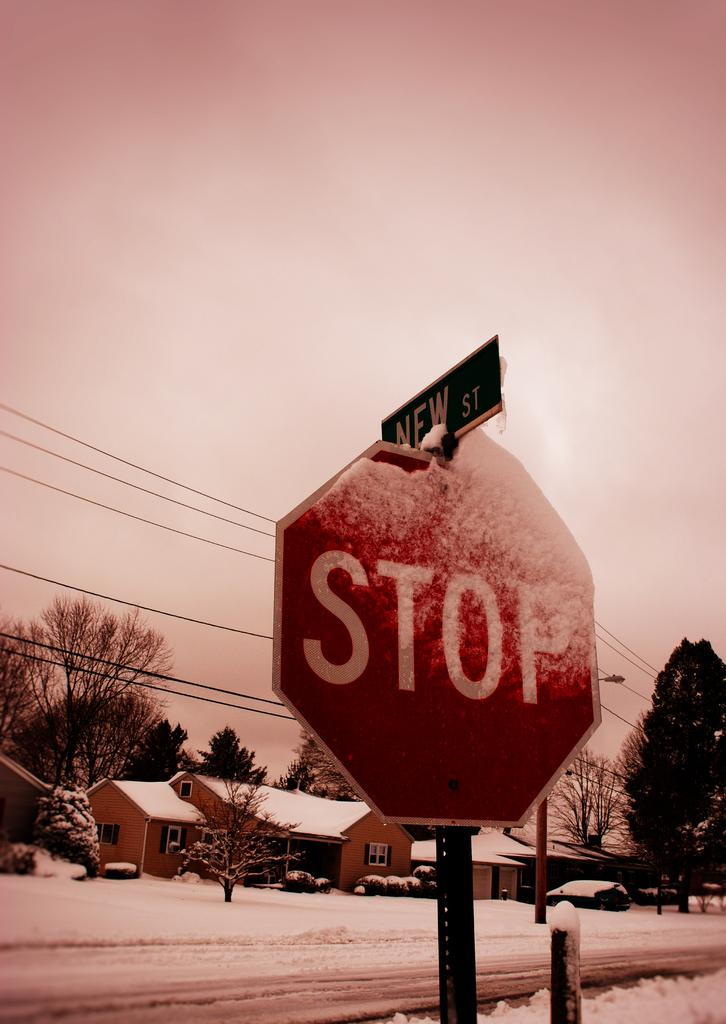Provide a one-sentence caption for the provided image. A stop sign in a snowy suburban area. 